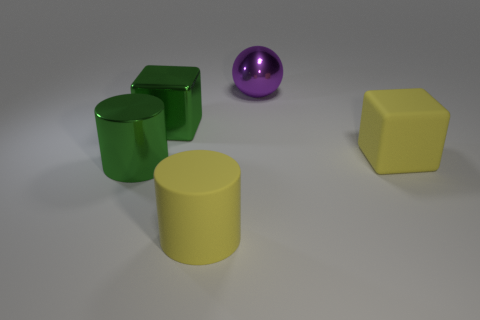Add 1 matte objects. How many objects exist? 6 Subtract all cylinders. How many objects are left? 3 Add 3 large gray shiny blocks. How many large gray shiny blocks exist? 3 Subtract 0 gray balls. How many objects are left? 5 Subtract all big objects. Subtract all small purple objects. How many objects are left? 0 Add 2 big green things. How many big green things are left? 4 